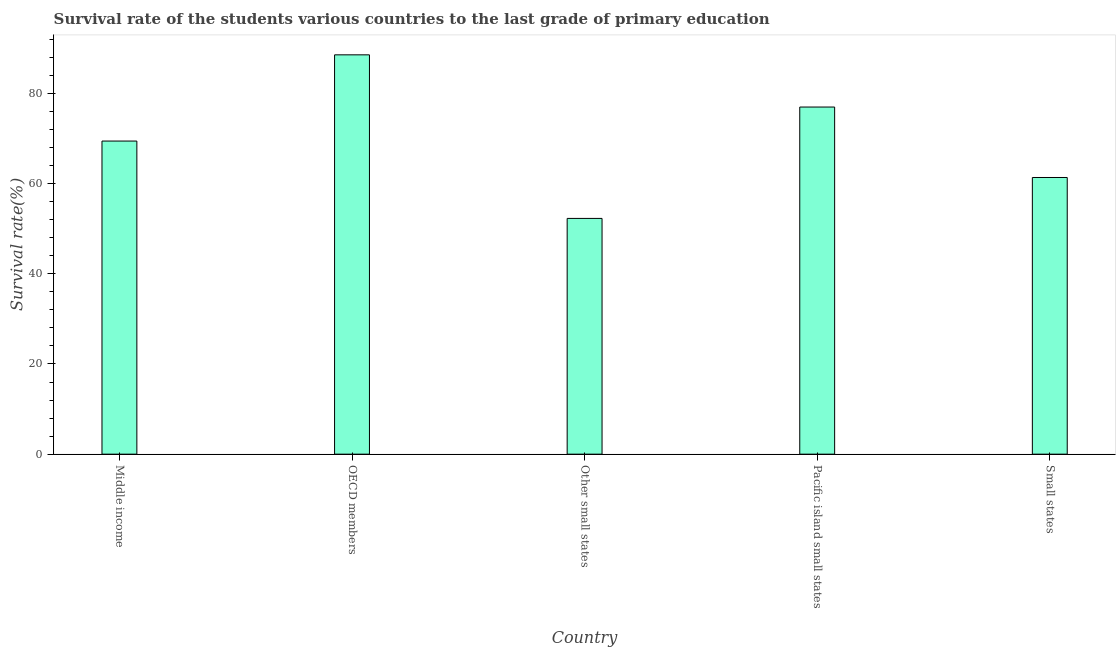Does the graph contain any zero values?
Provide a succinct answer. No. Does the graph contain grids?
Offer a very short reply. No. What is the title of the graph?
Keep it short and to the point. Survival rate of the students various countries to the last grade of primary education. What is the label or title of the Y-axis?
Make the answer very short. Survival rate(%). What is the survival rate in primary education in Pacific island small states?
Your answer should be very brief. 76.97. Across all countries, what is the maximum survival rate in primary education?
Your answer should be compact. 88.54. Across all countries, what is the minimum survival rate in primary education?
Keep it short and to the point. 52.27. In which country was the survival rate in primary education maximum?
Make the answer very short. OECD members. In which country was the survival rate in primary education minimum?
Your answer should be very brief. Other small states. What is the sum of the survival rate in primary education?
Offer a terse response. 348.54. What is the difference between the survival rate in primary education in OECD members and Other small states?
Your answer should be compact. 36.27. What is the average survival rate in primary education per country?
Keep it short and to the point. 69.71. What is the median survival rate in primary education?
Ensure brevity in your answer.  69.42. In how many countries, is the survival rate in primary education greater than 44 %?
Your answer should be compact. 5. What is the ratio of the survival rate in primary education in OECD members to that in Other small states?
Provide a succinct answer. 1.69. Is the difference between the survival rate in primary education in Middle income and Small states greater than the difference between any two countries?
Your answer should be very brief. No. What is the difference between the highest and the second highest survival rate in primary education?
Your answer should be very brief. 11.57. What is the difference between the highest and the lowest survival rate in primary education?
Keep it short and to the point. 36.27. How many bars are there?
Your response must be concise. 5. What is the difference between two consecutive major ticks on the Y-axis?
Provide a short and direct response. 20. What is the Survival rate(%) of Middle income?
Provide a succinct answer. 69.42. What is the Survival rate(%) in OECD members?
Your response must be concise. 88.54. What is the Survival rate(%) of Other small states?
Give a very brief answer. 52.27. What is the Survival rate(%) of Pacific island small states?
Keep it short and to the point. 76.97. What is the Survival rate(%) in Small states?
Your response must be concise. 61.34. What is the difference between the Survival rate(%) in Middle income and OECD members?
Make the answer very short. -19.11. What is the difference between the Survival rate(%) in Middle income and Other small states?
Give a very brief answer. 17.15. What is the difference between the Survival rate(%) in Middle income and Pacific island small states?
Provide a succinct answer. -7.54. What is the difference between the Survival rate(%) in Middle income and Small states?
Your answer should be compact. 8.08. What is the difference between the Survival rate(%) in OECD members and Other small states?
Provide a succinct answer. 36.27. What is the difference between the Survival rate(%) in OECD members and Pacific island small states?
Your response must be concise. 11.57. What is the difference between the Survival rate(%) in OECD members and Small states?
Make the answer very short. 27.2. What is the difference between the Survival rate(%) in Other small states and Pacific island small states?
Give a very brief answer. -24.7. What is the difference between the Survival rate(%) in Other small states and Small states?
Keep it short and to the point. -9.07. What is the difference between the Survival rate(%) in Pacific island small states and Small states?
Your answer should be very brief. 15.62. What is the ratio of the Survival rate(%) in Middle income to that in OECD members?
Offer a very short reply. 0.78. What is the ratio of the Survival rate(%) in Middle income to that in Other small states?
Ensure brevity in your answer.  1.33. What is the ratio of the Survival rate(%) in Middle income to that in Pacific island small states?
Your response must be concise. 0.9. What is the ratio of the Survival rate(%) in Middle income to that in Small states?
Provide a succinct answer. 1.13. What is the ratio of the Survival rate(%) in OECD members to that in Other small states?
Your answer should be very brief. 1.69. What is the ratio of the Survival rate(%) in OECD members to that in Pacific island small states?
Keep it short and to the point. 1.15. What is the ratio of the Survival rate(%) in OECD members to that in Small states?
Offer a terse response. 1.44. What is the ratio of the Survival rate(%) in Other small states to that in Pacific island small states?
Provide a short and direct response. 0.68. What is the ratio of the Survival rate(%) in Other small states to that in Small states?
Offer a terse response. 0.85. What is the ratio of the Survival rate(%) in Pacific island small states to that in Small states?
Give a very brief answer. 1.25. 